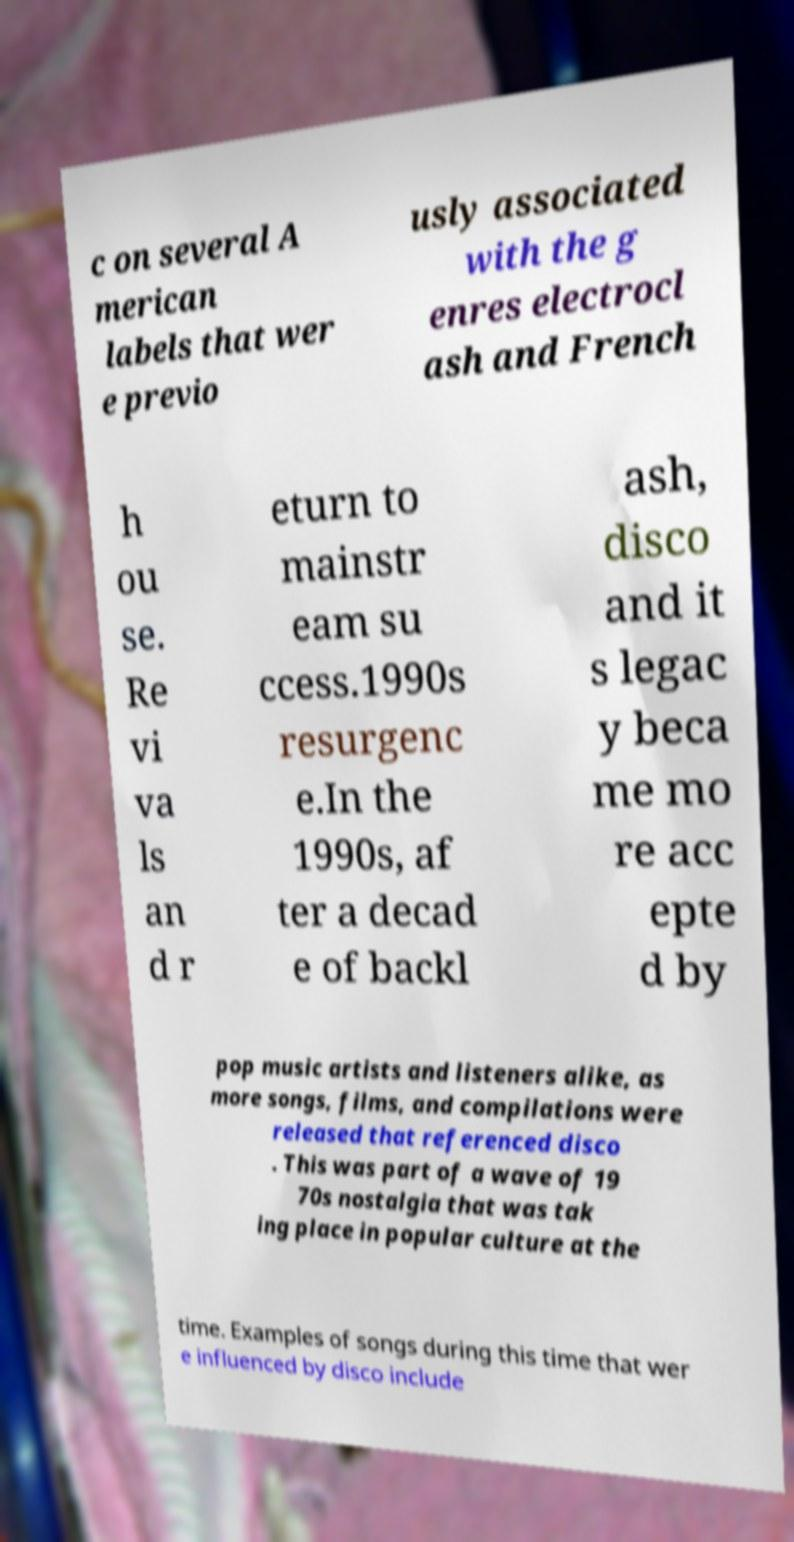There's text embedded in this image that I need extracted. Can you transcribe it verbatim? c on several A merican labels that wer e previo usly associated with the g enres electrocl ash and French h ou se. Re vi va ls an d r eturn to mainstr eam su ccess.1990s resurgenc e.In the 1990s, af ter a decad e of backl ash, disco and it s legac y beca me mo re acc epte d by pop music artists and listeners alike, as more songs, films, and compilations were released that referenced disco . This was part of a wave of 19 70s nostalgia that was tak ing place in popular culture at the time. Examples of songs during this time that wer e influenced by disco include 